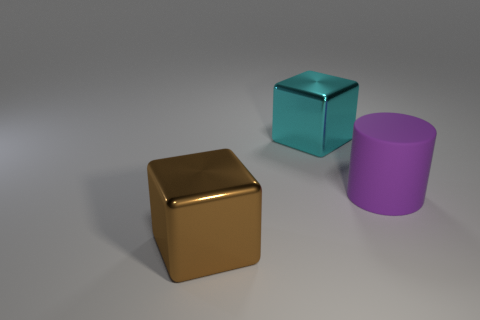What shape is the thing that is the same material as the big cyan cube?
Offer a very short reply. Cube. Are there any other things that are the same shape as the large brown thing?
Offer a terse response. Yes. There is a thing that is to the right of the big brown shiny object and on the left side of the purple matte object; what is its color?
Your response must be concise. Cyan. What number of cylinders are purple things or large cyan metal things?
Offer a very short reply. 1. What number of shiny blocks are the same size as the purple thing?
Offer a very short reply. 2. There is a cyan block behind the purple matte cylinder; what number of metallic blocks are to the left of it?
Offer a terse response. 1. What is the size of the object that is both on the left side of the purple cylinder and on the right side of the big brown cube?
Offer a very short reply. Large. Are there more shiny blocks than blue rubber objects?
Provide a succinct answer. Yes. There is a thing that is on the left side of the cyan metal cube; does it have the same size as the large cylinder?
Keep it short and to the point. Yes. Is the number of large brown metallic blocks less than the number of large brown cylinders?
Offer a terse response. No. 